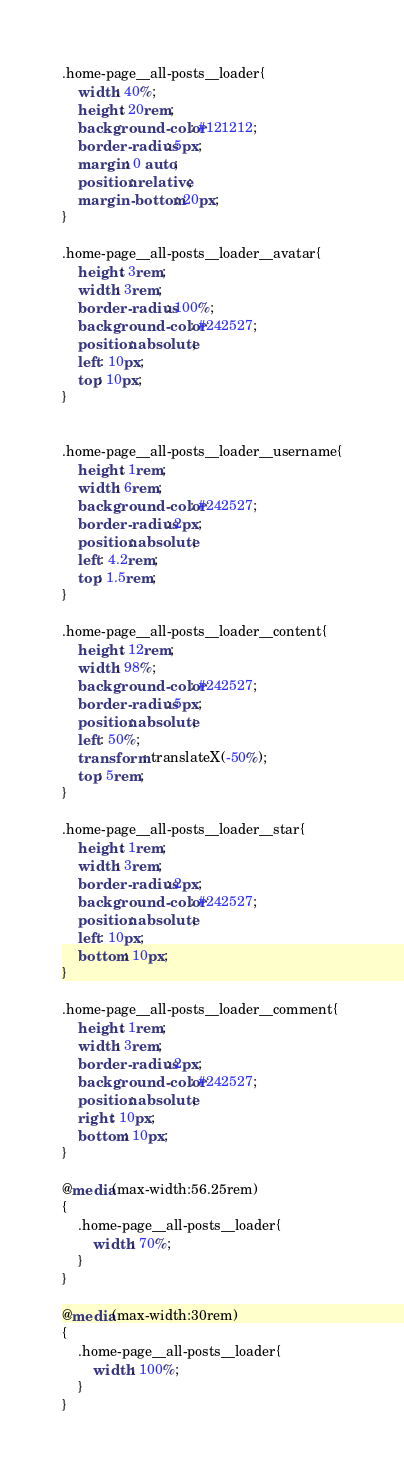Convert code to text. <code><loc_0><loc_0><loc_500><loc_500><_CSS_>.home-page__all-posts__loader{
    width: 40%;
    height: 20rem;
    background-color: #121212;
    border-radius: 5px;
    margin: 0 auto;
    position: relative;
    margin-bottom: 20px;
}

.home-page__all-posts__loader__avatar{
    height: 3rem;
    width: 3rem;
    border-radius: 100%;
    background-color: #242527;
    position: absolute;
    left: 10px;
    top: 10px;
}


.home-page__all-posts__loader__username{
    height: 1rem;
    width: 6rem;
    background-color: #242527;
    border-radius: 2px;
    position: absolute;
    left: 4.2rem;
    top: 1.5rem;
}

.home-page__all-posts__loader__content{
    height: 12rem;
    width: 98%;
    background-color: #242527;
    border-radius: 5px;
    position: absolute;
    left: 50%;
    transform: translateX(-50%);
    top: 5rem;
}

.home-page__all-posts__loader__star{
    height: 1rem;
    width: 3rem;
    border-radius: 2px;
    background-color: #242527;
    position: absolute;
    left: 10px;
    bottom: 10px;
}

.home-page__all-posts__loader__comment{
    height: 1rem;
    width: 3rem;
    border-radius: 2px;
    background-color: #242527;
    position: absolute;
    right: 10px;
    bottom: 10px;
}

@media(max-width:56.25rem)
{
    .home-page__all-posts__loader{
        width: 70%;
    }
}

@media(max-width:30rem)
{
    .home-page__all-posts__loader{
        width: 100%;
    }
}</code> 